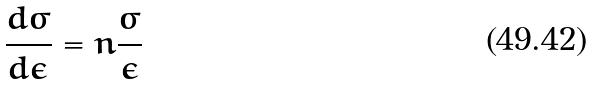Convert formula to latex. <formula><loc_0><loc_0><loc_500><loc_500>\frac { d \sigma } { d \epsilon } = n \frac { \sigma } { \epsilon }</formula> 